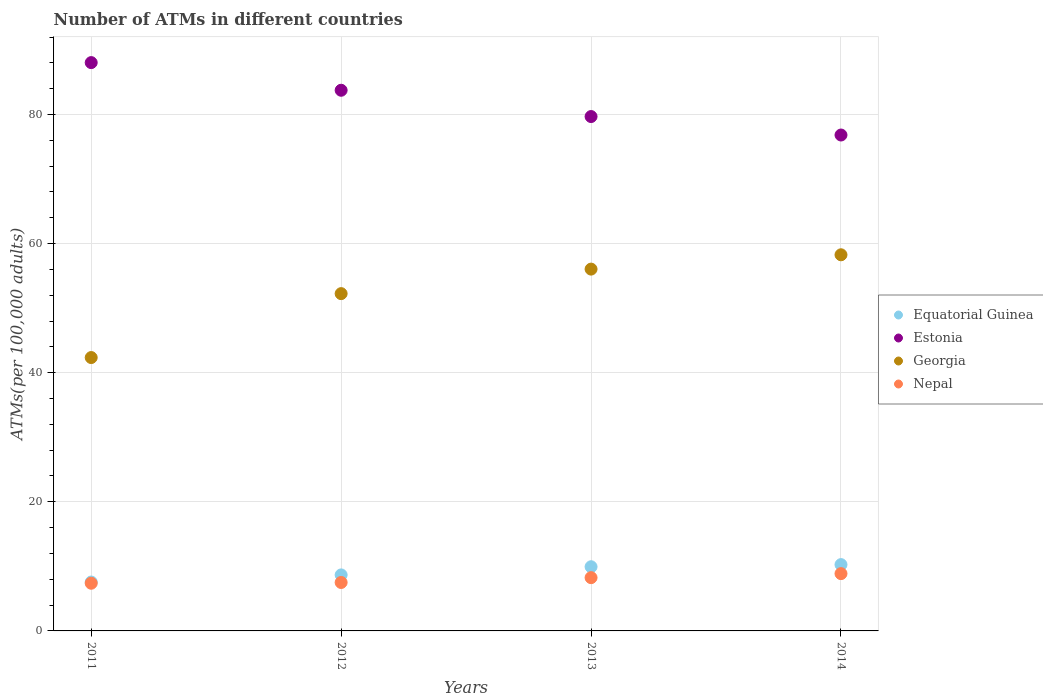What is the number of ATMs in Georgia in 2012?
Your answer should be very brief. 52.25. Across all years, what is the maximum number of ATMs in Equatorial Guinea?
Give a very brief answer. 10.27. Across all years, what is the minimum number of ATMs in Georgia?
Your answer should be compact. 42.35. In which year was the number of ATMs in Georgia maximum?
Give a very brief answer. 2014. In which year was the number of ATMs in Georgia minimum?
Your answer should be very brief. 2011. What is the total number of ATMs in Equatorial Guinea in the graph?
Keep it short and to the point. 36.46. What is the difference between the number of ATMs in Equatorial Guinea in 2012 and that in 2014?
Make the answer very short. -1.6. What is the difference between the number of ATMs in Georgia in 2011 and the number of ATMs in Nepal in 2013?
Keep it short and to the point. 34.09. What is the average number of ATMs in Equatorial Guinea per year?
Your answer should be compact. 9.12. In the year 2014, what is the difference between the number of ATMs in Equatorial Guinea and number of ATMs in Nepal?
Offer a very short reply. 1.4. What is the ratio of the number of ATMs in Nepal in 2012 to that in 2014?
Offer a very short reply. 0.85. Is the difference between the number of ATMs in Equatorial Guinea in 2011 and 2014 greater than the difference between the number of ATMs in Nepal in 2011 and 2014?
Offer a very short reply. No. What is the difference between the highest and the second highest number of ATMs in Georgia?
Make the answer very short. 2.22. What is the difference between the highest and the lowest number of ATMs in Georgia?
Offer a very short reply. 15.92. In how many years, is the number of ATMs in Georgia greater than the average number of ATMs in Georgia taken over all years?
Your response must be concise. 3. Does the number of ATMs in Nepal monotonically increase over the years?
Provide a short and direct response. Yes. Is the number of ATMs in Equatorial Guinea strictly less than the number of ATMs in Nepal over the years?
Your answer should be very brief. No. What is the difference between two consecutive major ticks on the Y-axis?
Your response must be concise. 20. Are the values on the major ticks of Y-axis written in scientific E-notation?
Offer a very short reply. No. Does the graph contain any zero values?
Provide a short and direct response. No. Where does the legend appear in the graph?
Your answer should be very brief. Center right. How are the legend labels stacked?
Your answer should be compact. Vertical. What is the title of the graph?
Provide a short and direct response. Number of ATMs in different countries. What is the label or title of the Y-axis?
Your answer should be compact. ATMs(per 100,0 adults). What is the ATMs(per 100,000 adults) of Equatorial Guinea in 2011?
Ensure brevity in your answer.  7.57. What is the ATMs(per 100,000 adults) of Estonia in 2011?
Give a very brief answer. 88.04. What is the ATMs(per 100,000 adults) in Georgia in 2011?
Keep it short and to the point. 42.35. What is the ATMs(per 100,000 adults) in Nepal in 2011?
Ensure brevity in your answer.  7.39. What is the ATMs(per 100,000 adults) in Equatorial Guinea in 2012?
Your answer should be very brief. 8.68. What is the ATMs(per 100,000 adults) of Estonia in 2012?
Your response must be concise. 83.75. What is the ATMs(per 100,000 adults) of Georgia in 2012?
Make the answer very short. 52.25. What is the ATMs(per 100,000 adults) in Nepal in 2012?
Provide a short and direct response. 7.5. What is the ATMs(per 100,000 adults) in Equatorial Guinea in 2013?
Make the answer very short. 9.94. What is the ATMs(per 100,000 adults) in Estonia in 2013?
Provide a succinct answer. 79.68. What is the ATMs(per 100,000 adults) of Georgia in 2013?
Keep it short and to the point. 56.05. What is the ATMs(per 100,000 adults) of Nepal in 2013?
Keep it short and to the point. 8.25. What is the ATMs(per 100,000 adults) of Equatorial Guinea in 2014?
Your answer should be compact. 10.27. What is the ATMs(per 100,000 adults) in Estonia in 2014?
Provide a succinct answer. 76.82. What is the ATMs(per 100,000 adults) in Georgia in 2014?
Provide a short and direct response. 58.27. What is the ATMs(per 100,000 adults) of Nepal in 2014?
Offer a very short reply. 8.88. Across all years, what is the maximum ATMs(per 100,000 adults) of Equatorial Guinea?
Provide a short and direct response. 10.27. Across all years, what is the maximum ATMs(per 100,000 adults) in Estonia?
Give a very brief answer. 88.04. Across all years, what is the maximum ATMs(per 100,000 adults) of Georgia?
Your response must be concise. 58.27. Across all years, what is the maximum ATMs(per 100,000 adults) in Nepal?
Provide a succinct answer. 8.88. Across all years, what is the minimum ATMs(per 100,000 adults) of Equatorial Guinea?
Ensure brevity in your answer.  7.57. Across all years, what is the minimum ATMs(per 100,000 adults) in Estonia?
Offer a very short reply. 76.82. Across all years, what is the minimum ATMs(per 100,000 adults) of Georgia?
Make the answer very short. 42.35. Across all years, what is the minimum ATMs(per 100,000 adults) of Nepal?
Give a very brief answer. 7.39. What is the total ATMs(per 100,000 adults) of Equatorial Guinea in the graph?
Offer a terse response. 36.46. What is the total ATMs(per 100,000 adults) in Estonia in the graph?
Provide a short and direct response. 328.29. What is the total ATMs(per 100,000 adults) of Georgia in the graph?
Provide a succinct answer. 208.91. What is the total ATMs(per 100,000 adults) in Nepal in the graph?
Give a very brief answer. 32.02. What is the difference between the ATMs(per 100,000 adults) in Equatorial Guinea in 2011 and that in 2012?
Keep it short and to the point. -1.1. What is the difference between the ATMs(per 100,000 adults) of Estonia in 2011 and that in 2012?
Provide a succinct answer. 4.28. What is the difference between the ATMs(per 100,000 adults) of Georgia in 2011 and that in 2012?
Offer a terse response. -9.9. What is the difference between the ATMs(per 100,000 adults) of Nepal in 2011 and that in 2012?
Make the answer very short. -0.12. What is the difference between the ATMs(per 100,000 adults) of Equatorial Guinea in 2011 and that in 2013?
Your response must be concise. -2.37. What is the difference between the ATMs(per 100,000 adults) in Estonia in 2011 and that in 2013?
Ensure brevity in your answer.  8.36. What is the difference between the ATMs(per 100,000 adults) in Georgia in 2011 and that in 2013?
Offer a very short reply. -13.7. What is the difference between the ATMs(per 100,000 adults) in Nepal in 2011 and that in 2013?
Ensure brevity in your answer.  -0.87. What is the difference between the ATMs(per 100,000 adults) of Equatorial Guinea in 2011 and that in 2014?
Provide a succinct answer. -2.7. What is the difference between the ATMs(per 100,000 adults) in Estonia in 2011 and that in 2014?
Provide a succinct answer. 11.22. What is the difference between the ATMs(per 100,000 adults) of Georgia in 2011 and that in 2014?
Offer a very short reply. -15.92. What is the difference between the ATMs(per 100,000 adults) of Nepal in 2011 and that in 2014?
Provide a short and direct response. -1.49. What is the difference between the ATMs(per 100,000 adults) of Equatorial Guinea in 2012 and that in 2013?
Provide a succinct answer. -1.27. What is the difference between the ATMs(per 100,000 adults) of Estonia in 2012 and that in 2013?
Your response must be concise. 4.07. What is the difference between the ATMs(per 100,000 adults) in Georgia in 2012 and that in 2013?
Offer a very short reply. -3.8. What is the difference between the ATMs(per 100,000 adults) in Nepal in 2012 and that in 2013?
Keep it short and to the point. -0.75. What is the difference between the ATMs(per 100,000 adults) of Equatorial Guinea in 2012 and that in 2014?
Your response must be concise. -1.6. What is the difference between the ATMs(per 100,000 adults) of Estonia in 2012 and that in 2014?
Your answer should be compact. 6.93. What is the difference between the ATMs(per 100,000 adults) of Georgia in 2012 and that in 2014?
Your answer should be very brief. -6.02. What is the difference between the ATMs(per 100,000 adults) of Nepal in 2012 and that in 2014?
Keep it short and to the point. -1.37. What is the difference between the ATMs(per 100,000 adults) of Equatorial Guinea in 2013 and that in 2014?
Ensure brevity in your answer.  -0.33. What is the difference between the ATMs(per 100,000 adults) of Estonia in 2013 and that in 2014?
Keep it short and to the point. 2.86. What is the difference between the ATMs(per 100,000 adults) of Georgia in 2013 and that in 2014?
Offer a terse response. -2.22. What is the difference between the ATMs(per 100,000 adults) in Nepal in 2013 and that in 2014?
Your answer should be very brief. -0.62. What is the difference between the ATMs(per 100,000 adults) in Equatorial Guinea in 2011 and the ATMs(per 100,000 adults) in Estonia in 2012?
Provide a succinct answer. -76.18. What is the difference between the ATMs(per 100,000 adults) of Equatorial Guinea in 2011 and the ATMs(per 100,000 adults) of Georgia in 2012?
Make the answer very short. -44.68. What is the difference between the ATMs(per 100,000 adults) of Equatorial Guinea in 2011 and the ATMs(per 100,000 adults) of Nepal in 2012?
Keep it short and to the point. 0.07. What is the difference between the ATMs(per 100,000 adults) in Estonia in 2011 and the ATMs(per 100,000 adults) in Georgia in 2012?
Offer a terse response. 35.79. What is the difference between the ATMs(per 100,000 adults) of Estonia in 2011 and the ATMs(per 100,000 adults) of Nepal in 2012?
Provide a short and direct response. 80.53. What is the difference between the ATMs(per 100,000 adults) in Georgia in 2011 and the ATMs(per 100,000 adults) in Nepal in 2012?
Make the answer very short. 34.84. What is the difference between the ATMs(per 100,000 adults) of Equatorial Guinea in 2011 and the ATMs(per 100,000 adults) of Estonia in 2013?
Offer a terse response. -72.11. What is the difference between the ATMs(per 100,000 adults) in Equatorial Guinea in 2011 and the ATMs(per 100,000 adults) in Georgia in 2013?
Offer a very short reply. -48.48. What is the difference between the ATMs(per 100,000 adults) of Equatorial Guinea in 2011 and the ATMs(per 100,000 adults) of Nepal in 2013?
Give a very brief answer. -0.68. What is the difference between the ATMs(per 100,000 adults) in Estonia in 2011 and the ATMs(per 100,000 adults) in Georgia in 2013?
Offer a very short reply. 31.99. What is the difference between the ATMs(per 100,000 adults) of Estonia in 2011 and the ATMs(per 100,000 adults) of Nepal in 2013?
Provide a succinct answer. 79.78. What is the difference between the ATMs(per 100,000 adults) in Georgia in 2011 and the ATMs(per 100,000 adults) in Nepal in 2013?
Ensure brevity in your answer.  34.09. What is the difference between the ATMs(per 100,000 adults) in Equatorial Guinea in 2011 and the ATMs(per 100,000 adults) in Estonia in 2014?
Your response must be concise. -69.25. What is the difference between the ATMs(per 100,000 adults) of Equatorial Guinea in 2011 and the ATMs(per 100,000 adults) of Georgia in 2014?
Make the answer very short. -50.69. What is the difference between the ATMs(per 100,000 adults) of Equatorial Guinea in 2011 and the ATMs(per 100,000 adults) of Nepal in 2014?
Provide a succinct answer. -1.3. What is the difference between the ATMs(per 100,000 adults) in Estonia in 2011 and the ATMs(per 100,000 adults) in Georgia in 2014?
Make the answer very short. 29.77. What is the difference between the ATMs(per 100,000 adults) in Estonia in 2011 and the ATMs(per 100,000 adults) in Nepal in 2014?
Make the answer very short. 79.16. What is the difference between the ATMs(per 100,000 adults) in Georgia in 2011 and the ATMs(per 100,000 adults) in Nepal in 2014?
Your response must be concise. 33.47. What is the difference between the ATMs(per 100,000 adults) in Equatorial Guinea in 2012 and the ATMs(per 100,000 adults) in Estonia in 2013?
Provide a short and direct response. -71. What is the difference between the ATMs(per 100,000 adults) of Equatorial Guinea in 2012 and the ATMs(per 100,000 adults) of Georgia in 2013?
Your answer should be compact. -47.37. What is the difference between the ATMs(per 100,000 adults) of Equatorial Guinea in 2012 and the ATMs(per 100,000 adults) of Nepal in 2013?
Provide a short and direct response. 0.42. What is the difference between the ATMs(per 100,000 adults) in Estonia in 2012 and the ATMs(per 100,000 adults) in Georgia in 2013?
Your response must be concise. 27.71. What is the difference between the ATMs(per 100,000 adults) of Estonia in 2012 and the ATMs(per 100,000 adults) of Nepal in 2013?
Keep it short and to the point. 75.5. What is the difference between the ATMs(per 100,000 adults) of Georgia in 2012 and the ATMs(per 100,000 adults) of Nepal in 2013?
Offer a terse response. 44. What is the difference between the ATMs(per 100,000 adults) of Equatorial Guinea in 2012 and the ATMs(per 100,000 adults) of Estonia in 2014?
Ensure brevity in your answer.  -68.14. What is the difference between the ATMs(per 100,000 adults) in Equatorial Guinea in 2012 and the ATMs(per 100,000 adults) in Georgia in 2014?
Your response must be concise. -49.59. What is the difference between the ATMs(per 100,000 adults) in Equatorial Guinea in 2012 and the ATMs(per 100,000 adults) in Nepal in 2014?
Provide a short and direct response. -0.2. What is the difference between the ATMs(per 100,000 adults) of Estonia in 2012 and the ATMs(per 100,000 adults) of Georgia in 2014?
Provide a short and direct response. 25.49. What is the difference between the ATMs(per 100,000 adults) of Estonia in 2012 and the ATMs(per 100,000 adults) of Nepal in 2014?
Your answer should be compact. 74.88. What is the difference between the ATMs(per 100,000 adults) in Georgia in 2012 and the ATMs(per 100,000 adults) in Nepal in 2014?
Your answer should be compact. 43.37. What is the difference between the ATMs(per 100,000 adults) of Equatorial Guinea in 2013 and the ATMs(per 100,000 adults) of Estonia in 2014?
Give a very brief answer. -66.88. What is the difference between the ATMs(per 100,000 adults) in Equatorial Guinea in 2013 and the ATMs(per 100,000 adults) in Georgia in 2014?
Your answer should be compact. -48.32. What is the difference between the ATMs(per 100,000 adults) in Equatorial Guinea in 2013 and the ATMs(per 100,000 adults) in Nepal in 2014?
Your answer should be compact. 1.07. What is the difference between the ATMs(per 100,000 adults) in Estonia in 2013 and the ATMs(per 100,000 adults) in Georgia in 2014?
Give a very brief answer. 21.41. What is the difference between the ATMs(per 100,000 adults) of Estonia in 2013 and the ATMs(per 100,000 adults) of Nepal in 2014?
Provide a short and direct response. 70.81. What is the difference between the ATMs(per 100,000 adults) of Georgia in 2013 and the ATMs(per 100,000 adults) of Nepal in 2014?
Provide a succinct answer. 47.17. What is the average ATMs(per 100,000 adults) in Equatorial Guinea per year?
Provide a succinct answer. 9.12. What is the average ATMs(per 100,000 adults) of Estonia per year?
Offer a very short reply. 82.07. What is the average ATMs(per 100,000 adults) of Georgia per year?
Your answer should be very brief. 52.23. What is the average ATMs(per 100,000 adults) of Nepal per year?
Offer a very short reply. 8. In the year 2011, what is the difference between the ATMs(per 100,000 adults) of Equatorial Guinea and ATMs(per 100,000 adults) of Estonia?
Provide a succinct answer. -80.47. In the year 2011, what is the difference between the ATMs(per 100,000 adults) in Equatorial Guinea and ATMs(per 100,000 adults) in Georgia?
Your response must be concise. -34.78. In the year 2011, what is the difference between the ATMs(per 100,000 adults) of Equatorial Guinea and ATMs(per 100,000 adults) of Nepal?
Your response must be concise. 0.19. In the year 2011, what is the difference between the ATMs(per 100,000 adults) in Estonia and ATMs(per 100,000 adults) in Georgia?
Ensure brevity in your answer.  45.69. In the year 2011, what is the difference between the ATMs(per 100,000 adults) in Estonia and ATMs(per 100,000 adults) in Nepal?
Make the answer very short. 80.65. In the year 2011, what is the difference between the ATMs(per 100,000 adults) of Georgia and ATMs(per 100,000 adults) of Nepal?
Your answer should be very brief. 34.96. In the year 2012, what is the difference between the ATMs(per 100,000 adults) in Equatorial Guinea and ATMs(per 100,000 adults) in Estonia?
Your answer should be very brief. -75.08. In the year 2012, what is the difference between the ATMs(per 100,000 adults) of Equatorial Guinea and ATMs(per 100,000 adults) of Georgia?
Offer a terse response. -43.57. In the year 2012, what is the difference between the ATMs(per 100,000 adults) of Equatorial Guinea and ATMs(per 100,000 adults) of Nepal?
Your answer should be very brief. 1.17. In the year 2012, what is the difference between the ATMs(per 100,000 adults) of Estonia and ATMs(per 100,000 adults) of Georgia?
Make the answer very short. 31.5. In the year 2012, what is the difference between the ATMs(per 100,000 adults) of Estonia and ATMs(per 100,000 adults) of Nepal?
Your answer should be very brief. 76.25. In the year 2012, what is the difference between the ATMs(per 100,000 adults) in Georgia and ATMs(per 100,000 adults) in Nepal?
Offer a very short reply. 44.75. In the year 2013, what is the difference between the ATMs(per 100,000 adults) of Equatorial Guinea and ATMs(per 100,000 adults) of Estonia?
Provide a short and direct response. -69.74. In the year 2013, what is the difference between the ATMs(per 100,000 adults) of Equatorial Guinea and ATMs(per 100,000 adults) of Georgia?
Offer a very short reply. -46.11. In the year 2013, what is the difference between the ATMs(per 100,000 adults) in Equatorial Guinea and ATMs(per 100,000 adults) in Nepal?
Your response must be concise. 1.69. In the year 2013, what is the difference between the ATMs(per 100,000 adults) in Estonia and ATMs(per 100,000 adults) in Georgia?
Offer a very short reply. 23.63. In the year 2013, what is the difference between the ATMs(per 100,000 adults) of Estonia and ATMs(per 100,000 adults) of Nepal?
Keep it short and to the point. 71.43. In the year 2013, what is the difference between the ATMs(per 100,000 adults) of Georgia and ATMs(per 100,000 adults) of Nepal?
Your response must be concise. 47.8. In the year 2014, what is the difference between the ATMs(per 100,000 adults) in Equatorial Guinea and ATMs(per 100,000 adults) in Estonia?
Offer a terse response. -66.55. In the year 2014, what is the difference between the ATMs(per 100,000 adults) in Equatorial Guinea and ATMs(per 100,000 adults) in Georgia?
Ensure brevity in your answer.  -47.99. In the year 2014, what is the difference between the ATMs(per 100,000 adults) of Equatorial Guinea and ATMs(per 100,000 adults) of Nepal?
Your answer should be very brief. 1.4. In the year 2014, what is the difference between the ATMs(per 100,000 adults) in Estonia and ATMs(per 100,000 adults) in Georgia?
Provide a succinct answer. 18.55. In the year 2014, what is the difference between the ATMs(per 100,000 adults) of Estonia and ATMs(per 100,000 adults) of Nepal?
Give a very brief answer. 67.94. In the year 2014, what is the difference between the ATMs(per 100,000 adults) of Georgia and ATMs(per 100,000 adults) of Nepal?
Offer a terse response. 49.39. What is the ratio of the ATMs(per 100,000 adults) of Equatorial Guinea in 2011 to that in 2012?
Keep it short and to the point. 0.87. What is the ratio of the ATMs(per 100,000 adults) of Estonia in 2011 to that in 2012?
Give a very brief answer. 1.05. What is the ratio of the ATMs(per 100,000 adults) in Georgia in 2011 to that in 2012?
Offer a very short reply. 0.81. What is the ratio of the ATMs(per 100,000 adults) of Nepal in 2011 to that in 2012?
Provide a short and direct response. 0.98. What is the ratio of the ATMs(per 100,000 adults) of Equatorial Guinea in 2011 to that in 2013?
Provide a short and direct response. 0.76. What is the ratio of the ATMs(per 100,000 adults) of Estonia in 2011 to that in 2013?
Your answer should be very brief. 1.1. What is the ratio of the ATMs(per 100,000 adults) in Georgia in 2011 to that in 2013?
Your answer should be very brief. 0.76. What is the ratio of the ATMs(per 100,000 adults) of Nepal in 2011 to that in 2013?
Give a very brief answer. 0.9. What is the ratio of the ATMs(per 100,000 adults) in Equatorial Guinea in 2011 to that in 2014?
Provide a succinct answer. 0.74. What is the ratio of the ATMs(per 100,000 adults) in Estonia in 2011 to that in 2014?
Provide a short and direct response. 1.15. What is the ratio of the ATMs(per 100,000 adults) of Georgia in 2011 to that in 2014?
Make the answer very short. 0.73. What is the ratio of the ATMs(per 100,000 adults) of Nepal in 2011 to that in 2014?
Make the answer very short. 0.83. What is the ratio of the ATMs(per 100,000 adults) in Equatorial Guinea in 2012 to that in 2013?
Provide a succinct answer. 0.87. What is the ratio of the ATMs(per 100,000 adults) in Estonia in 2012 to that in 2013?
Offer a very short reply. 1.05. What is the ratio of the ATMs(per 100,000 adults) of Georgia in 2012 to that in 2013?
Make the answer very short. 0.93. What is the ratio of the ATMs(per 100,000 adults) of Equatorial Guinea in 2012 to that in 2014?
Your answer should be very brief. 0.84. What is the ratio of the ATMs(per 100,000 adults) of Estonia in 2012 to that in 2014?
Make the answer very short. 1.09. What is the ratio of the ATMs(per 100,000 adults) of Georgia in 2012 to that in 2014?
Your response must be concise. 0.9. What is the ratio of the ATMs(per 100,000 adults) in Nepal in 2012 to that in 2014?
Keep it short and to the point. 0.85. What is the ratio of the ATMs(per 100,000 adults) in Equatorial Guinea in 2013 to that in 2014?
Provide a succinct answer. 0.97. What is the ratio of the ATMs(per 100,000 adults) of Estonia in 2013 to that in 2014?
Keep it short and to the point. 1.04. What is the ratio of the ATMs(per 100,000 adults) of Georgia in 2013 to that in 2014?
Ensure brevity in your answer.  0.96. What is the ratio of the ATMs(per 100,000 adults) in Nepal in 2013 to that in 2014?
Offer a terse response. 0.93. What is the difference between the highest and the second highest ATMs(per 100,000 adults) of Equatorial Guinea?
Provide a short and direct response. 0.33. What is the difference between the highest and the second highest ATMs(per 100,000 adults) in Estonia?
Keep it short and to the point. 4.28. What is the difference between the highest and the second highest ATMs(per 100,000 adults) of Georgia?
Your response must be concise. 2.22. What is the difference between the highest and the second highest ATMs(per 100,000 adults) in Nepal?
Provide a succinct answer. 0.62. What is the difference between the highest and the lowest ATMs(per 100,000 adults) in Equatorial Guinea?
Your response must be concise. 2.7. What is the difference between the highest and the lowest ATMs(per 100,000 adults) in Estonia?
Provide a short and direct response. 11.22. What is the difference between the highest and the lowest ATMs(per 100,000 adults) of Georgia?
Your answer should be very brief. 15.92. What is the difference between the highest and the lowest ATMs(per 100,000 adults) of Nepal?
Keep it short and to the point. 1.49. 